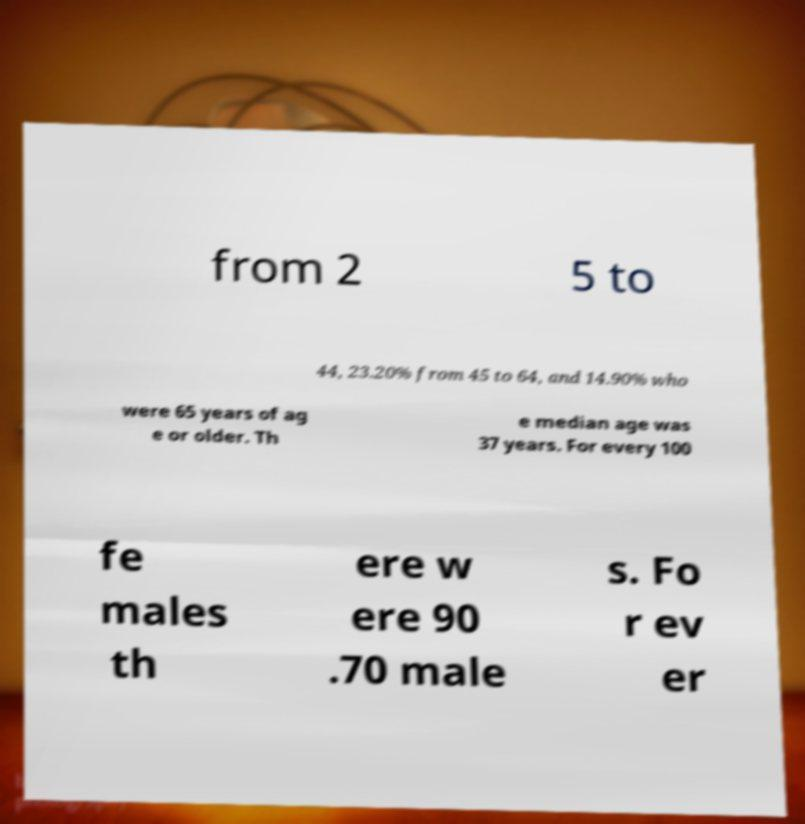Could you extract and type out the text from this image? from 2 5 to 44, 23.20% from 45 to 64, and 14.90% who were 65 years of ag e or older. Th e median age was 37 years. For every 100 fe males th ere w ere 90 .70 male s. Fo r ev er 